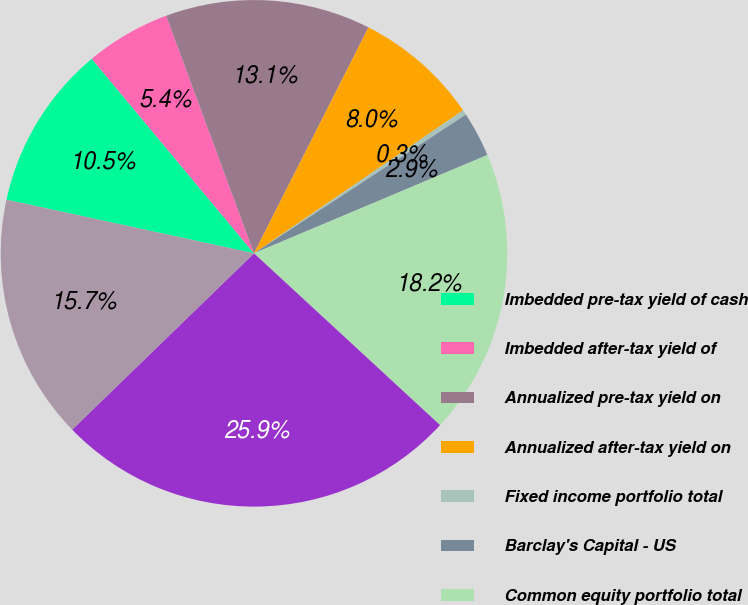<chart> <loc_0><loc_0><loc_500><loc_500><pie_chart><fcel>Imbedded pre-tax yield of cash<fcel>Imbedded after-tax yield of<fcel>Annualized pre-tax yield on<fcel>Annualized after-tax yield on<fcel>Fixed income portfolio total<fcel>Barclay's Capital - US<fcel>Common equity portfolio total<fcel>S&P 500 index<fcel>Other invested asset portfolio<nl><fcel>10.54%<fcel>5.43%<fcel>13.1%<fcel>7.99%<fcel>0.32%<fcel>2.88%<fcel>18.21%<fcel>25.88%<fcel>15.65%<nl></chart> 